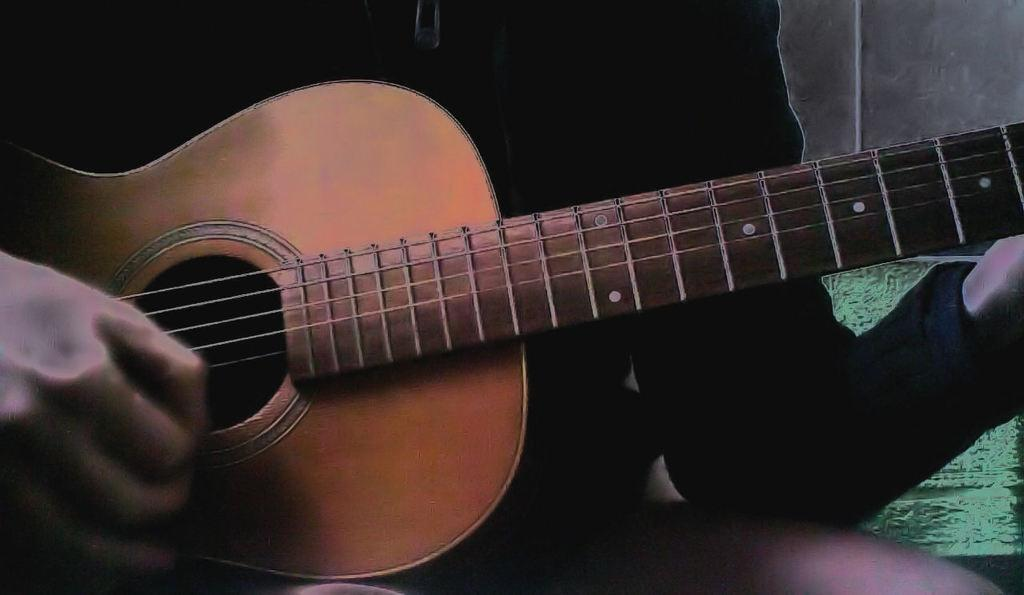How was the image altered or changed? The image is edited. What can be seen behind the person in the image? There is a wall in the background of the image. What is the person doing in the image? The person is sitting in the middle of the image and playing music. What instrument is the person playing? The person is holding a guitar. What type of comb is the person using to play the guitar in the image? There is no comb present in the image, and the person is not using any comb to play the guitar. 